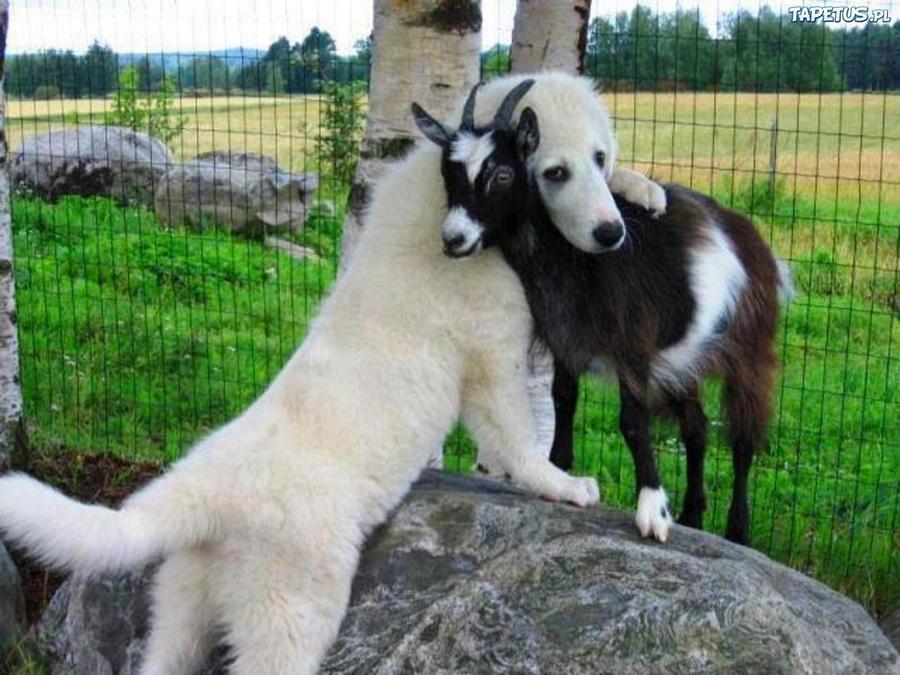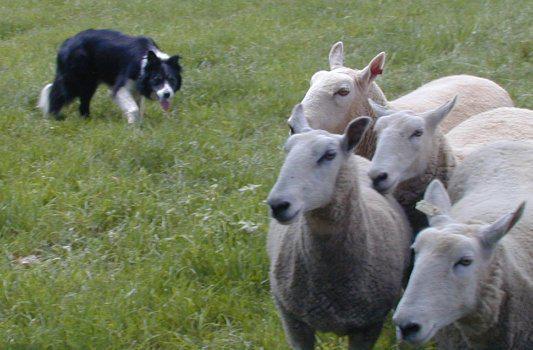The first image is the image on the left, the second image is the image on the right. Considering the images on both sides, is "One of the images contains exactly three sheep" valid? Answer yes or no. No. The first image is the image on the left, the second image is the image on the right. Given the left and right images, does the statement "An image shows just one herd dog behind and to the left of a group of sheep." hold true? Answer yes or no. Yes. 